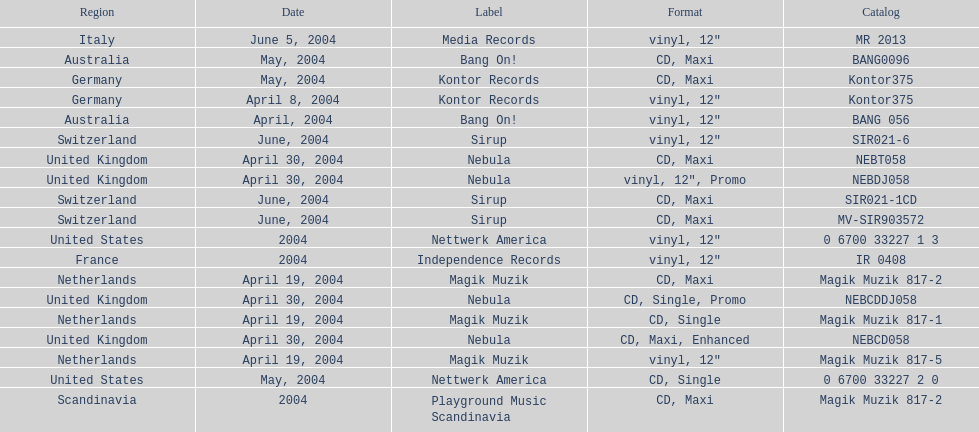Could you parse the entire table as a dict? {'header': ['Region', 'Date', 'Label', 'Format', 'Catalog'], 'rows': [['Italy', 'June 5, 2004', 'Media Records', 'vinyl, 12"', 'MR 2013'], ['Australia', 'May, 2004', 'Bang On!', 'CD, Maxi', 'BANG0096'], ['Germany', 'May, 2004', 'Kontor Records', 'CD, Maxi', 'Kontor375'], ['Germany', 'April 8, 2004', 'Kontor Records', 'vinyl, 12"', 'Kontor375'], ['Australia', 'April, 2004', 'Bang On!', 'vinyl, 12"', 'BANG 056'], ['Switzerland', 'June, 2004', 'Sirup', 'vinyl, 12"', 'SIR021-6'], ['United Kingdom', 'April 30, 2004', 'Nebula', 'CD, Maxi', 'NEBT058'], ['United Kingdom', 'April 30, 2004', 'Nebula', 'vinyl, 12", Promo', 'NEBDJ058'], ['Switzerland', 'June, 2004', 'Sirup', 'CD, Maxi', 'SIR021-1CD'], ['Switzerland', 'June, 2004', 'Sirup', 'CD, Maxi', 'MV-SIR903572'], ['United States', '2004', 'Nettwerk America', 'vinyl, 12"', '0 6700 33227 1 3'], ['France', '2004', 'Independence Records', 'vinyl, 12"', 'IR 0408'], ['Netherlands', 'April 19, 2004', 'Magik Muzik', 'CD, Maxi', 'Magik Muzik 817-2'], ['United Kingdom', 'April 30, 2004', 'Nebula', 'CD, Single, Promo', 'NEBCDDJ058'], ['Netherlands', 'April 19, 2004', 'Magik Muzik', 'CD, Single', 'Magik Muzik 817-1'], ['United Kingdom', 'April 30, 2004', 'Nebula', 'CD, Maxi, Enhanced', 'NEBCD058'], ['Netherlands', 'April 19, 2004', 'Magik Muzik', 'vinyl, 12"', 'Magik Muzik 817-5'], ['United States', 'May, 2004', 'Nettwerk America', 'CD, Single', '0 6700 33227 2 0'], ['Scandinavia', '2004', 'Playground Music Scandinavia', 'CD, Maxi', 'Magik Muzik 817-2']]} What region is listed at the top? Netherlands. 